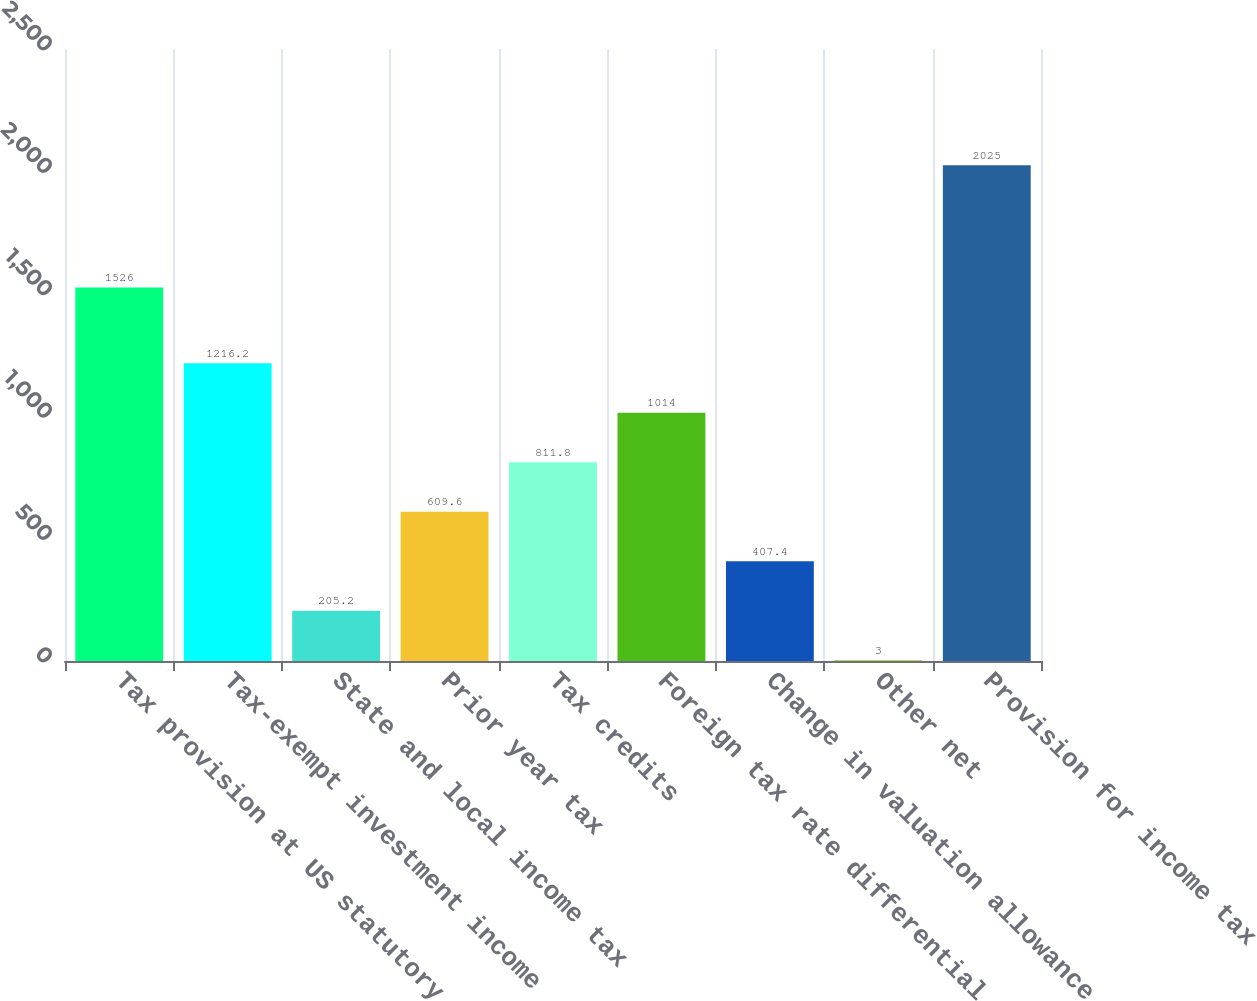Convert chart. <chart><loc_0><loc_0><loc_500><loc_500><bar_chart><fcel>Tax provision at US statutory<fcel>Tax-exempt investment income<fcel>State and local income tax<fcel>Prior year tax<fcel>Tax credits<fcel>Foreign tax rate differential<fcel>Change in valuation allowance<fcel>Other net<fcel>Provision for income tax<nl><fcel>1526<fcel>1216.2<fcel>205.2<fcel>609.6<fcel>811.8<fcel>1014<fcel>407.4<fcel>3<fcel>2025<nl></chart> 